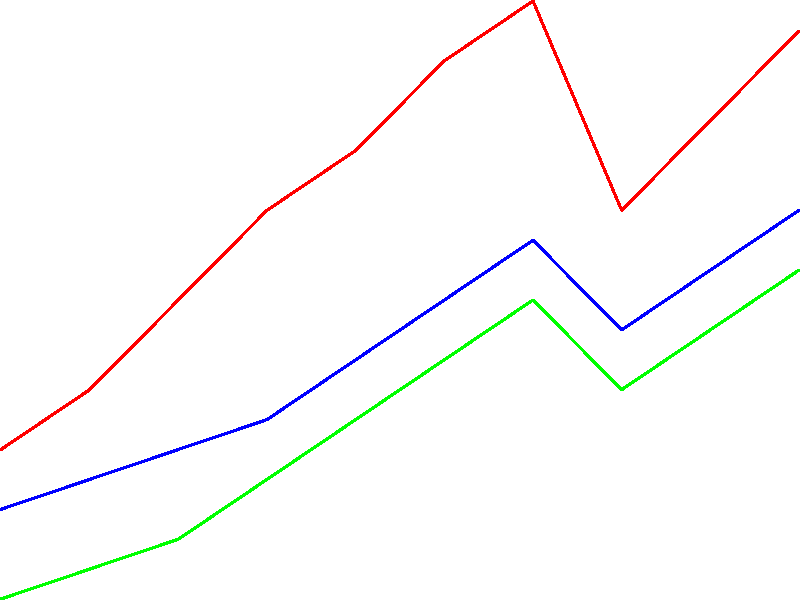Based on the line graph showing volunteer participation trends in various charity events over the past decade, which event experienced the most significant decline in participation during 2020, and what factors specific to Israel might have contributed to this decrease? To answer this question, we need to analyze the graph and consider the context of Israel:

1. Examine the three lines representing different charity events:
   - Red line: Food Drive
   - Blue line: Clothing Collection
   - Green line: Education Support

2. Locate the year 2020 on the x-axis and observe the changes in each line:
   - Food Drive: Drops from about 250 to 180 volunteers
   - Clothing Collection: Drops from about 170 to 140 volunteers
   - Education Support: Drops from about 150 to 120 volunteers

3. Calculate the percentage decrease for each event:
   - Food Drive: $(250 - 180) / 250 \times 100\% \approx 28\%$
   - Clothing Collection: $(170 - 140) / 170 \times 100\% \approx 17.6\%$
   - Education Support: $(150 - 120) / 150 \times 100\% \approx 20\%$

4. The Food Drive experienced the most significant decline in participation during 2020.

5. Factors specific to Israel that might have contributed to this decrease:
   - COVID-19 pandemic: Israel implemented strict lockdowns and social distancing measures.
   - Economic impact: Many Israelis faced financial difficulties, potentially reducing their ability to volunteer.
   - Health concerns: People may have been hesitant to participate in food-related activities due to virus transmission fears.
   - Shift to online activities: Education support may have been easier to transition online compared to food drives.
   - Government support: Israel's social welfare system may have stepped up to provide food assistance, reducing the need for volunteers.
Answer: Food Drive (28% decrease); COVID-19 pandemic and related restrictions in Israel. 